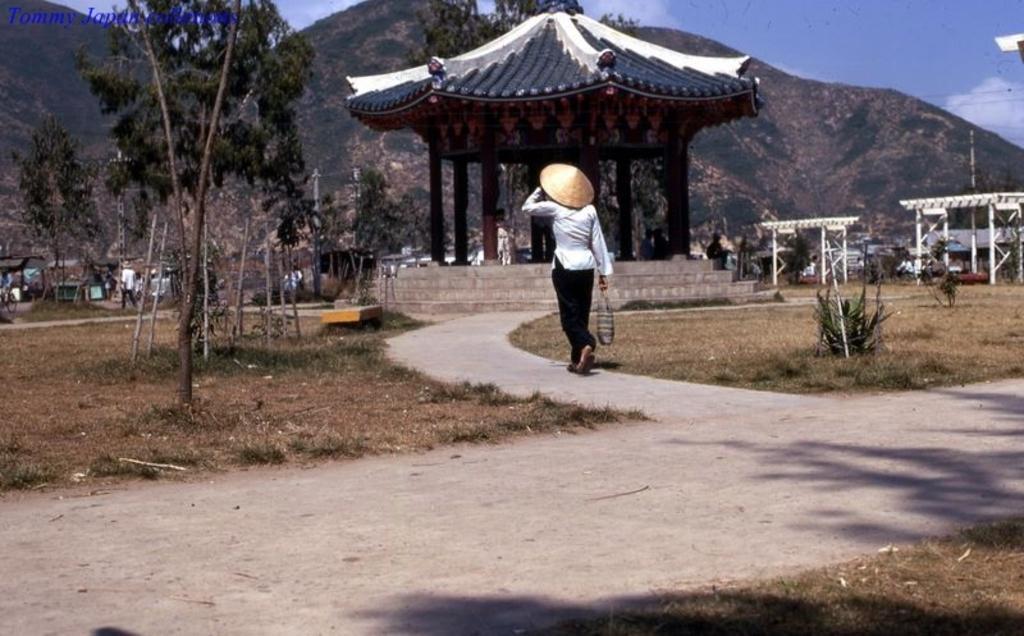In one or two sentences, can you explain what this image depicts? In the picture I can see people, trees, plants, a Chinese house without side walls, poles, wires and some other things. In the background I can see mountains and the sky. 